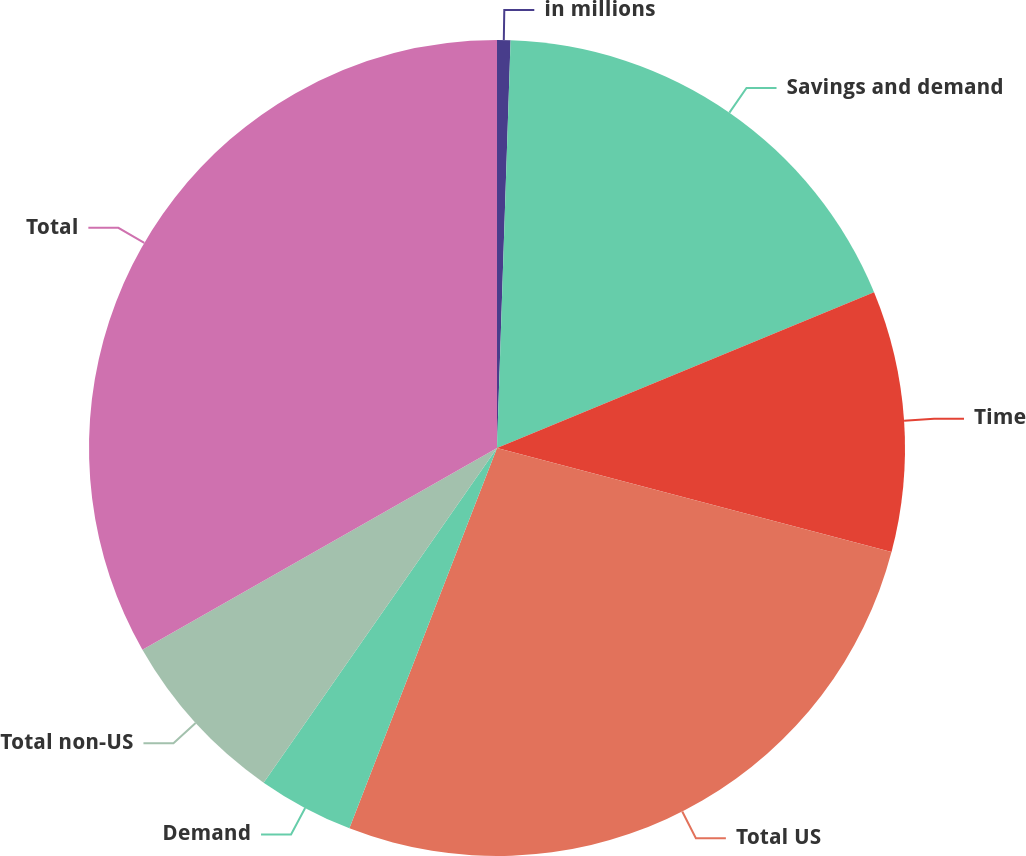<chart> <loc_0><loc_0><loc_500><loc_500><pie_chart><fcel>in millions<fcel>Savings and demand<fcel>Time<fcel>Total US<fcel>Demand<fcel>Total non-US<fcel>Total<nl><fcel>0.53%<fcel>18.23%<fcel>10.34%<fcel>26.78%<fcel>3.8%<fcel>7.07%<fcel>33.23%<nl></chart> 